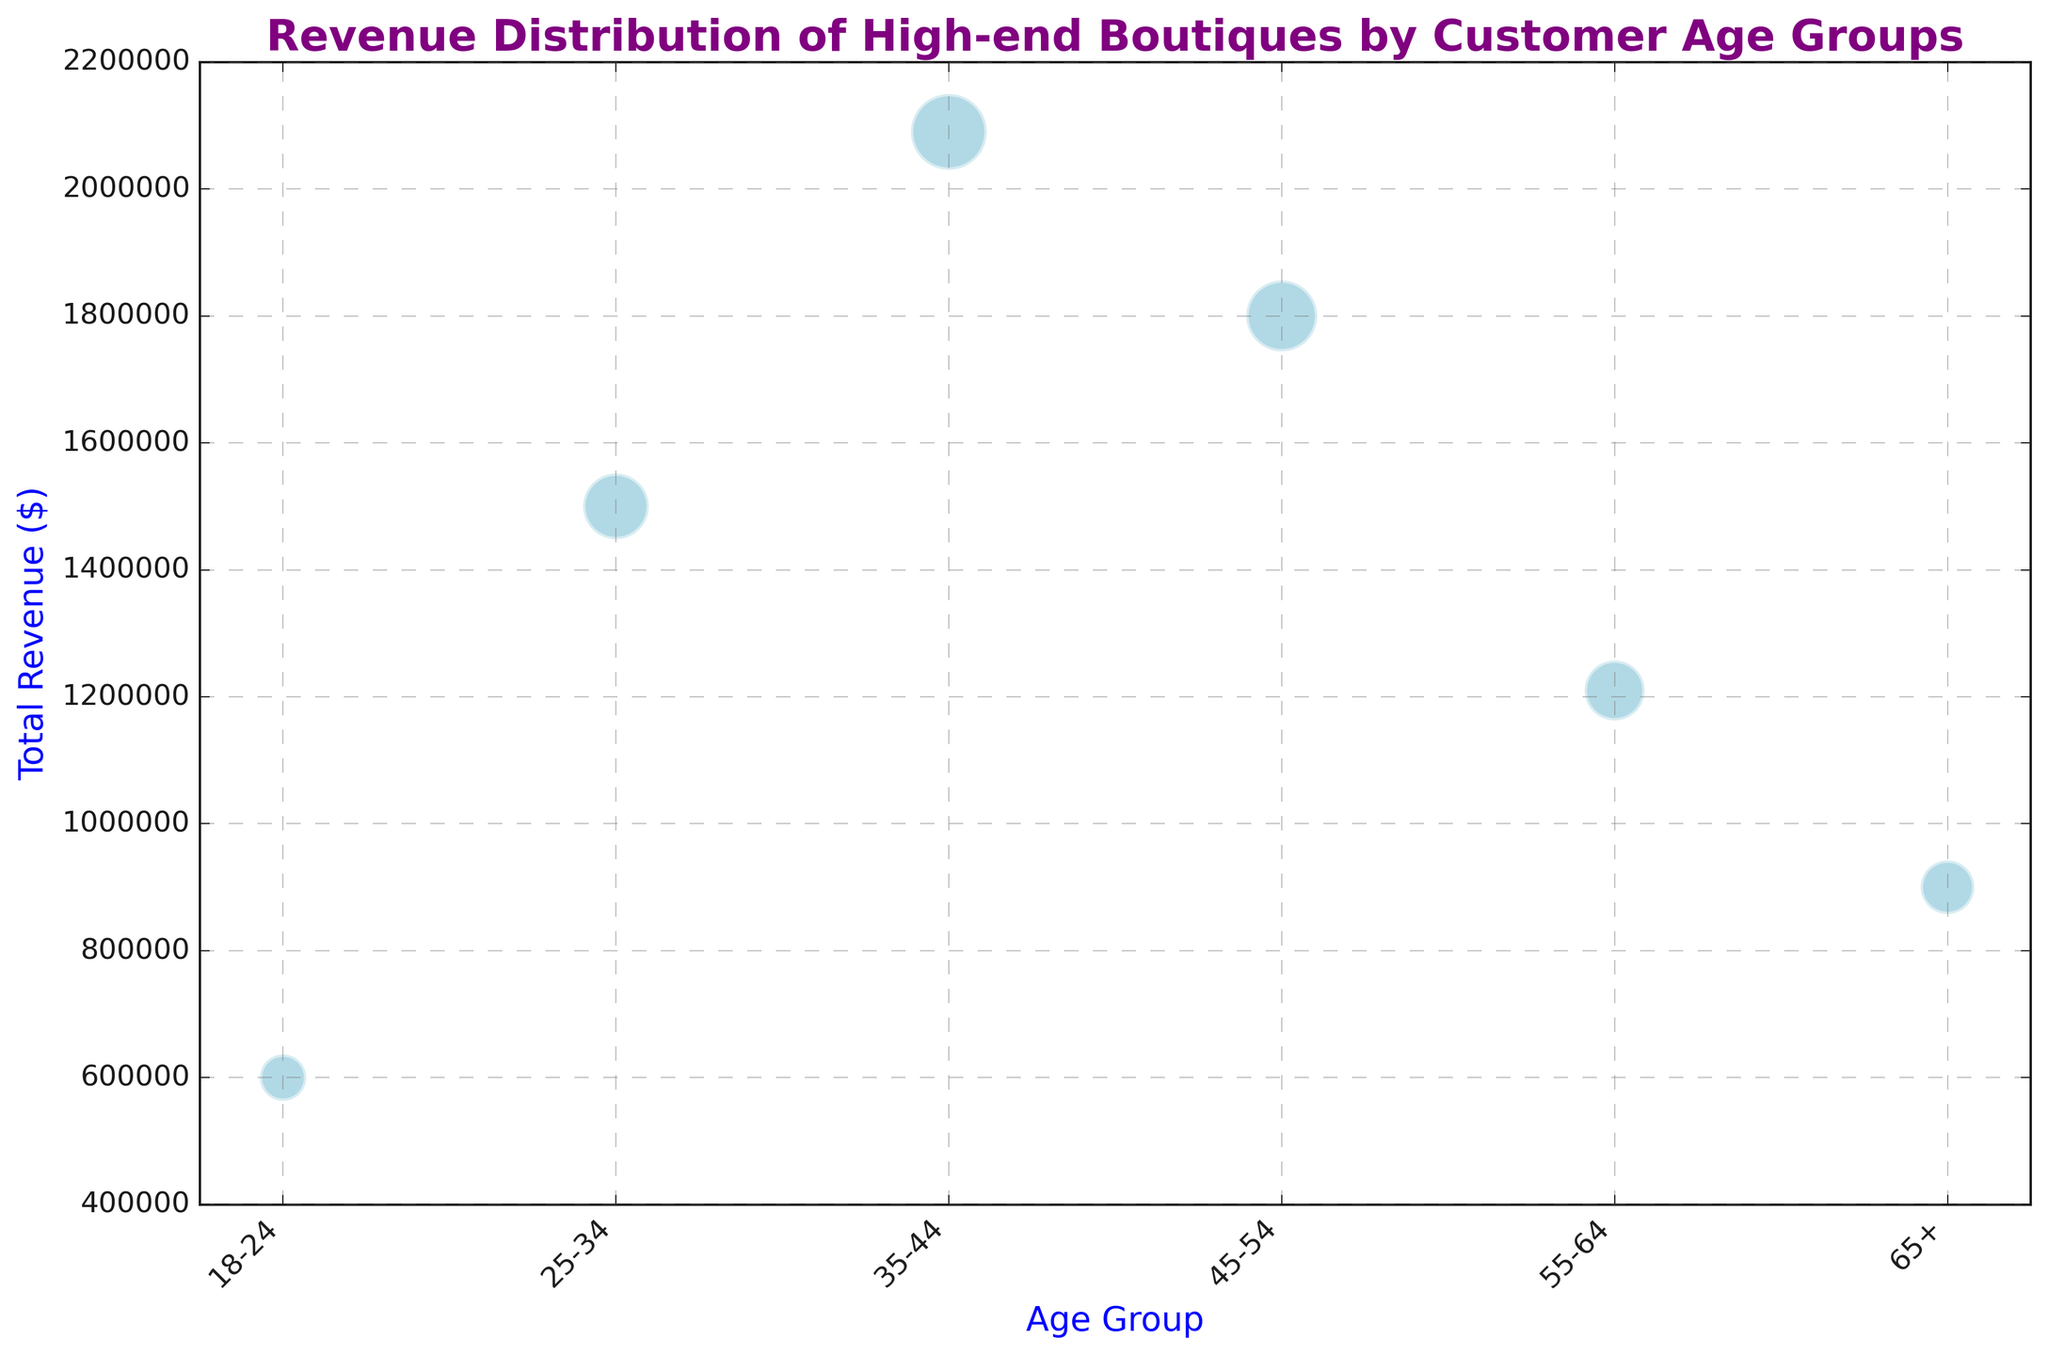What is the age group that generated the highest total revenue? The age group with the highest bubble along the y-axis represents the highest revenue.
Answer: 35-44 How does the total revenue of customers aged 18-24 compare to those aged 65+? Compare the height of the bubbles on the y-axis for the age groups 18-24 and 65+. The 18-24 group has higher revenue.
Answer: 18-24 has higher revenue Which age group has the largest number of customers? The size of the bubble represents the number of customers. The largest bubble corresponds to the 35-44 age group.
Answer: 35-44 What is the total revenue generated by the age groups 45-54 and 25-34 combined? Sum the total revenues for the age groups 45-54 and 25-34. Their revenues are 1,200,000 and 1,500,000, respectively, resulting in 1,200,000 + 1,500,000 = 2,700,000.
Answer: 2,700,000 Which age group shows the lowest total revenue, and what is the value? The bubble with the lowest position on the y-axis shows the lowest revenue. The age group 18-24 has the lowest revenue compared to other age groups.
Answer: 18-24, 600,000 How does the number of customers in the 55-64 age group compare to the 25-34 age group? Compare the sizes of the bubbles. The 25-34 age group has a larger bubble size than the 55-64 age group, indicating more customers.
Answer: 25-34 has more customers Which age group has a lower number of customers, 65+ or 18-24, and by how much? Compare the sizes of the bubbles. The bubble for 65+ is smaller than for 18-24. 18-24 has 450 customers, and 65+ has 600 customers. 600 - 450 = 150.
Answer: 18-24, by 150 What is the visual distinction between the age groups in terms of bubble size and placement? The larger the bubble size, the more customers. Higher placement on the y-axis means higher revenue. Age group 35-44 has the largest bubble and the highest placement, while 18-24 has the smallest bubble placed lower.
Answer: Size represents customers, height represents revenue If the age group 45-54 increases their revenue by $200,000, will they surpass the 35-44 age group in total revenue? Current revenue for 45-54 is 1,800,000. Adding 200,000 brings it to 2,000,000. The 35-44 age group has a revenue of 2,090,000. 2,090,000 > 2,000,000.
Answer: No What is the difference in total revenue between the age groups 35-44 and 55-64? Subtract the total revenue of 55-64 from that of 35-44: 2,090,000 - 1,210,000 = 880,000.
Answer: 880,000 